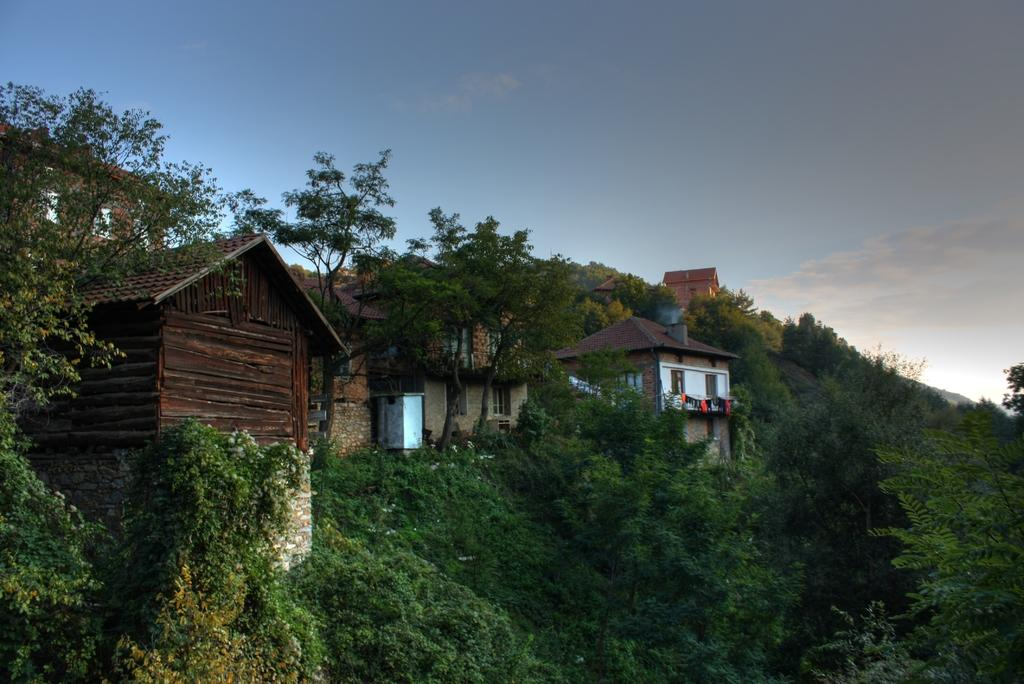What type of structures can be seen in the image? There are buildings in the image. What other natural elements are present in the image? There are trees in the image. What part of the environment is visible in the image? The sky is visible in the image. What type of treatment is being administered to the tail of the hammer in the image? There is no hammer or tail present in the image. 